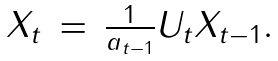<formula> <loc_0><loc_0><loc_500><loc_500>\begin{array} { r c l } X _ { t } & = & \frac { 1 } { a _ { t - 1 } } U _ { t } X _ { t - 1 } . \end{array}</formula> 